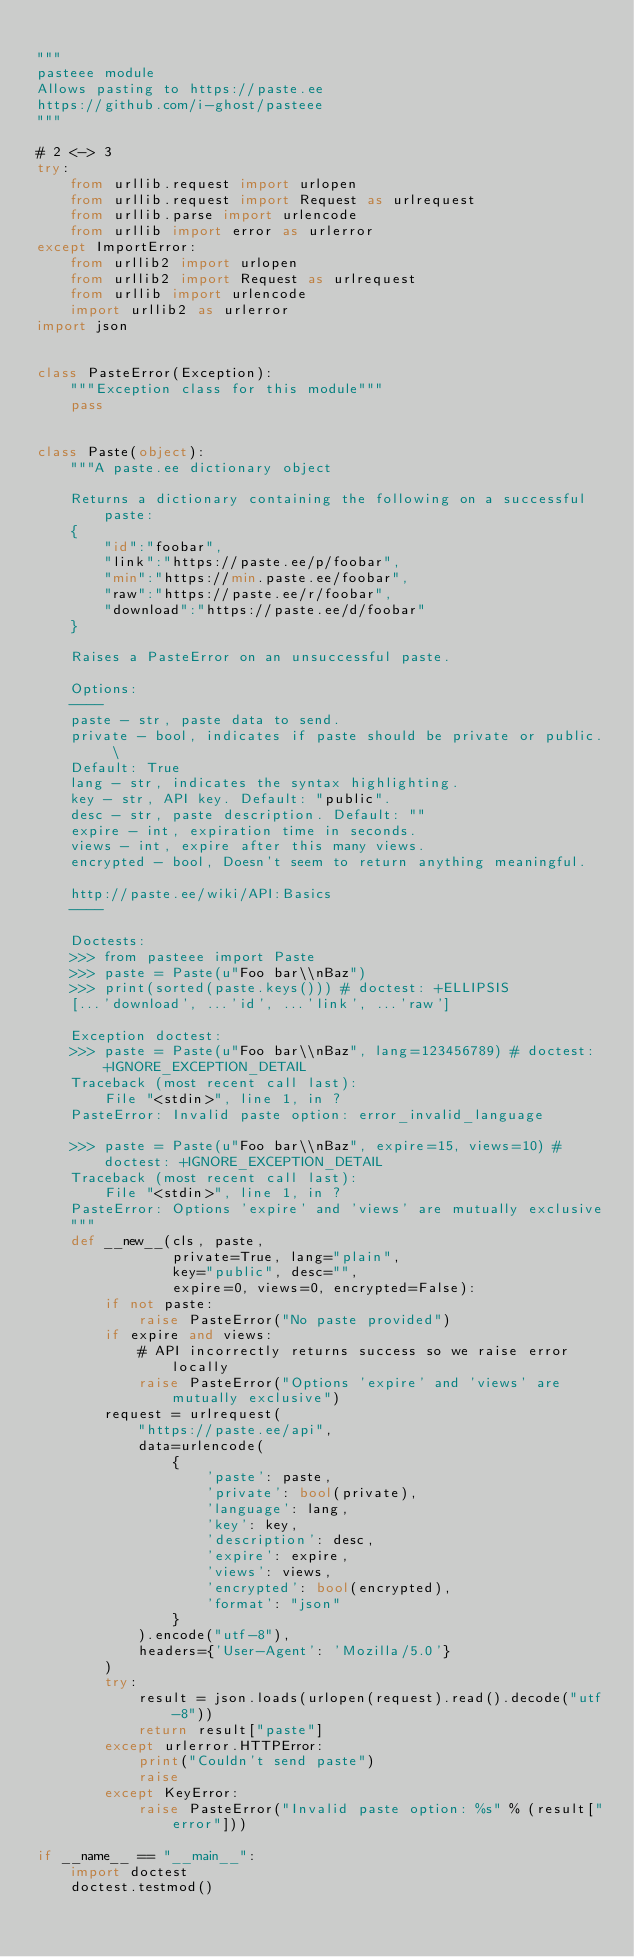<code> <loc_0><loc_0><loc_500><loc_500><_Python_>
"""
pasteee module
Allows pasting to https://paste.ee
https://github.com/i-ghost/pasteee
"""

# 2 <-> 3
try:
    from urllib.request import urlopen
    from urllib.request import Request as urlrequest
    from urllib.parse import urlencode
    from urllib import error as urlerror
except ImportError:
    from urllib2 import urlopen
    from urllib2 import Request as urlrequest
    from urllib import urlencode
    import urllib2 as urlerror
import json


class PasteError(Exception):
    """Exception class for this module"""
    pass


class Paste(object):
    """A paste.ee dictionary object

    Returns a dictionary containing the following on a successful paste:
    {
        "id":"foobar",
        "link":"https://paste.ee/p/foobar",
        "min":"https://min.paste.ee/foobar",
        "raw":"https://paste.ee/r/foobar",
        "download":"https://paste.ee/d/foobar"
    }

    Raises a PasteError on an unsuccessful paste.

    Options:
    ----
    paste - str, paste data to send.
    private - bool, indicates if paste should be private or public. \
    Default: True
    lang - str, indicates the syntax highlighting.
    key - str, API key. Default: "public".
    desc - str, paste description. Default: ""
    expire - int, expiration time in seconds.
    views - int, expire after this many views.
    encrypted - bool, Doesn't seem to return anything meaningful.

    http://paste.ee/wiki/API:Basics
    ----

    Doctests:
    >>> from pasteee import Paste
    >>> paste = Paste(u"Foo bar\\nBaz")
    >>> print(sorted(paste.keys())) # doctest: +ELLIPSIS
    [...'download', ...'id', ...'link', ...'raw']

    Exception doctest:
    >>> paste = Paste(u"Foo bar\\nBaz", lang=123456789) # doctest: +IGNORE_EXCEPTION_DETAIL
    Traceback (most recent call last):
        File "<stdin>", line 1, in ?
    PasteError: Invalid paste option: error_invalid_language

    >>> paste = Paste(u"Foo bar\\nBaz", expire=15, views=10) # doctest: +IGNORE_EXCEPTION_DETAIL
    Traceback (most recent call last):
        File "<stdin>", line 1, in ?
    PasteError: Options 'expire' and 'views' are mutually exclusive
    """
    def __new__(cls, paste,
                private=True, lang="plain",
                key="public", desc="",
                expire=0, views=0, encrypted=False):
        if not paste:
            raise PasteError("No paste provided")
        if expire and views:
            # API incorrectly returns success so we raise error locally
            raise PasteError("Options 'expire' and 'views' are mutually exclusive")
        request = urlrequest(
            "https://paste.ee/api",
            data=urlencode(
                {
                    'paste': paste,
                    'private': bool(private),
                    'language': lang,
                    'key': key,
                    'description': desc,
                    'expire': expire,
                    'views': views,
                    'encrypted': bool(encrypted),
                    'format': "json"
                }
            ).encode("utf-8"),
            headers={'User-Agent': 'Mozilla/5.0'}
        )
        try:
            result = json.loads(urlopen(request).read().decode("utf-8"))
            return result["paste"]
        except urlerror.HTTPError:
            print("Couldn't send paste")
            raise
        except KeyError:
            raise PasteError("Invalid paste option: %s" % (result["error"]))

if __name__ == "__main__":
    import doctest
    doctest.testmod()
</code> 